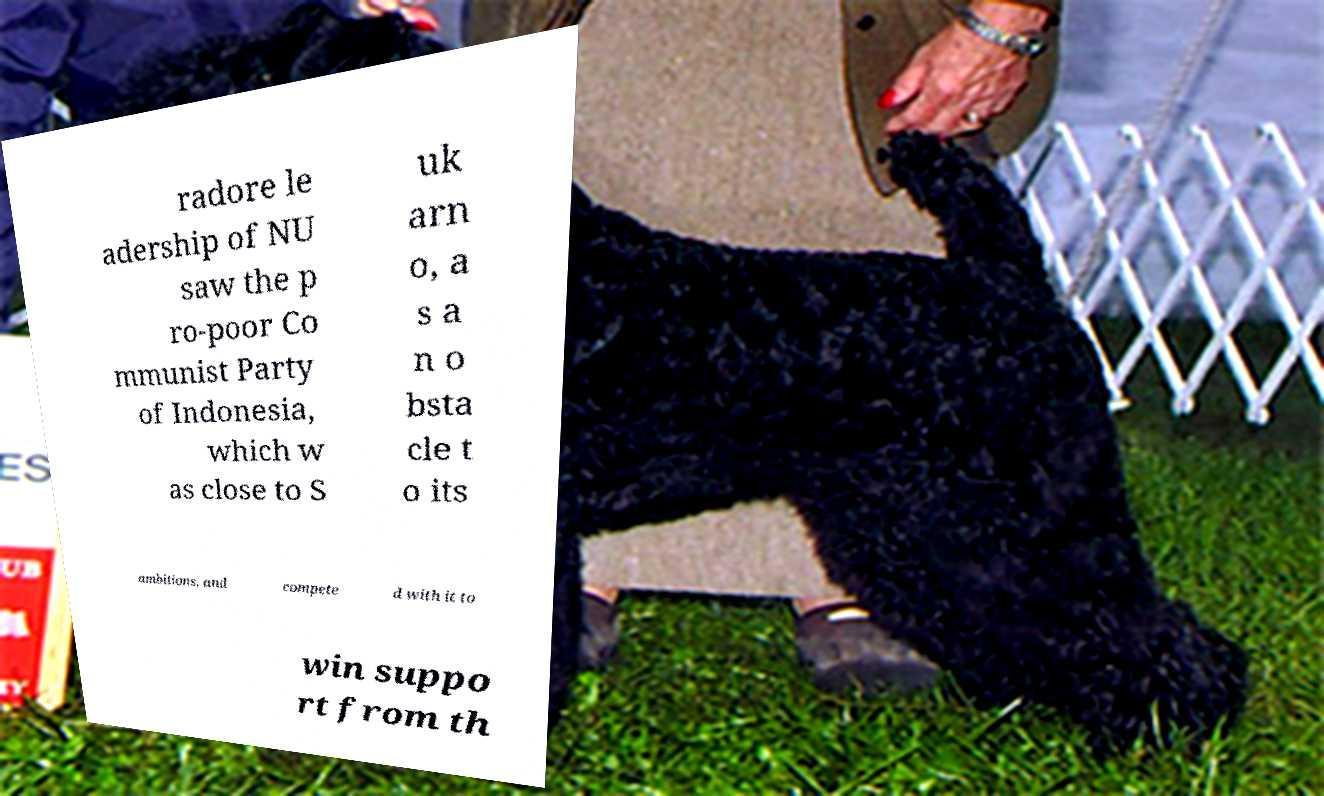Please identify and transcribe the text found in this image. radore le adership of NU saw the p ro-poor Co mmunist Party of Indonesia, which w as close to S uk arn o, a s a n o bsta cle t o its ambitions, and compete d with it to win suppo rt from th 